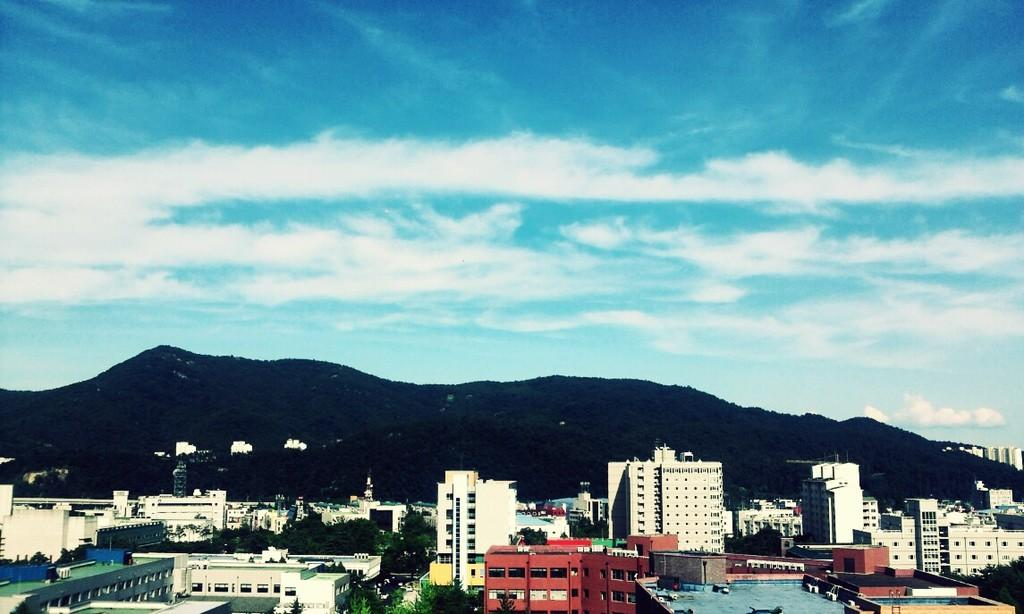What type of structures can be seen in the image? There is a group of buildings in the image. What natural elements are present in the image? There are trees and water visible in the image. Can you describe the objects in the image? There are objects in the image, but their specific nature is not mentioned in the facts. What is visible in the background of the image? There are mountains and the sky visible in the background of the image. What is the condition of the sky in the image? The sky is visible in the background of the image, and clouds are present. Can you tell me how many visitors are interacting with the balloon in the image? There is no balloon or visitor present in the image. How does the touch of the mountains affect the water in the image? The mountains do not physically touch the water in the image, so there is no interaction between them. 